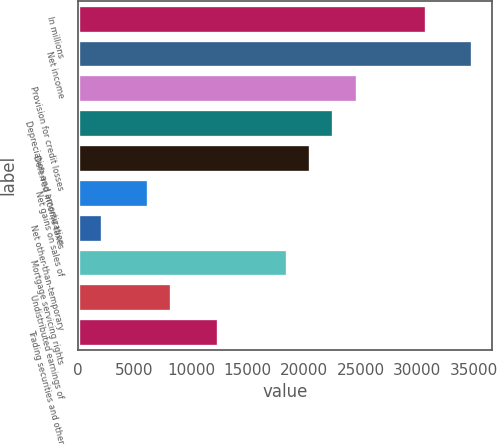Convert chart to OTSL. <chart><loc_0><loc_0><loc_500><loc_500><bar_chart><fcel>In millions<fcel>Net income<fcel>Provision for credit losses<fcel>Depreciation and amortization<fcel>Deferred income taxes<fcel>Net gains on sales of<fcel>Net other-than-temporary<fcel>Mortgage servicing rights<fcel>Undistributed earnings of<fcel>Trading securities and other<nl><fcel>30761<fcel>34852.2<fcel>24624.2<fcel>22578.6<fcel>20533<fcel>6213.8<fcel>2122.6<fcel>18487.4<fcel>8259.4<fcel>12350.6<nl></chart> 